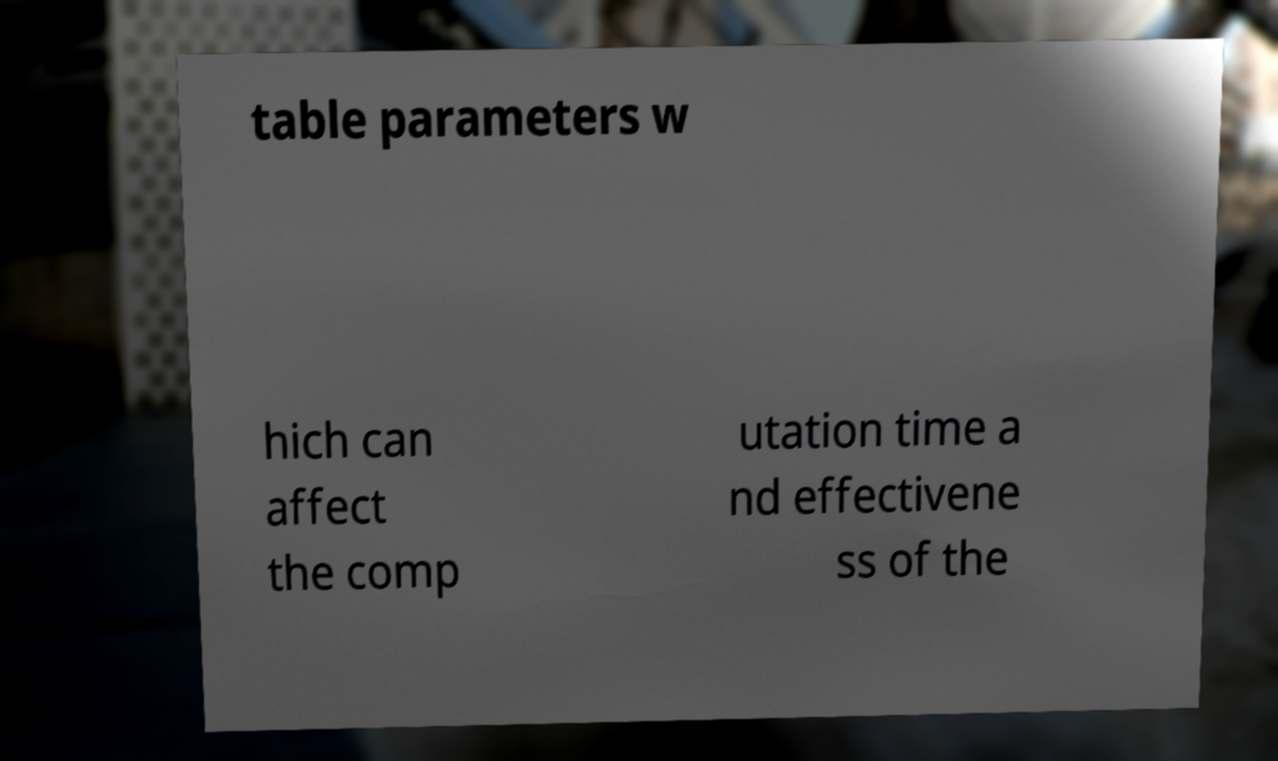Can you read and provide the text displayed in the image?This photo seems to have some interesting text. Can you extract and type it out for me? table parameters w hich can affect the comp utation time a nd effectivene ss of the 